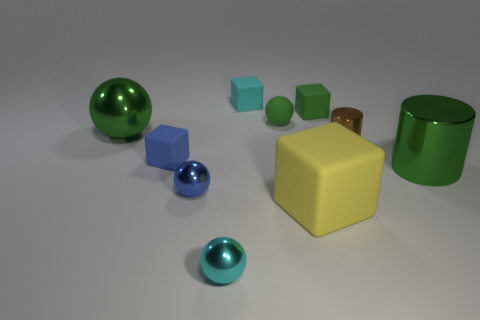Subtract all green cylinders. How many cylinders are left? 1 Subtract all tiny matte cubes. How many cubes are left? 1 Subtract all red balls. Subtract all red cubes. How many balls are left? 4 Add 9 big green shiny spheres. How many big green shiny spheres exist? 10 Subtract 0 cyan cylinders. How many objects are left? 10 Subtract all cylinders. How many objects are left? 8 Subtract 1 cubes. How many cubes are left? 3 Subtract all yellow balls. How many brown cylinders are left? 1 Subtract all brown cylinders. Subtract all matte blocks. How many objects are left? 5 Add 7 blue objects. How many blue objects are left? 9 